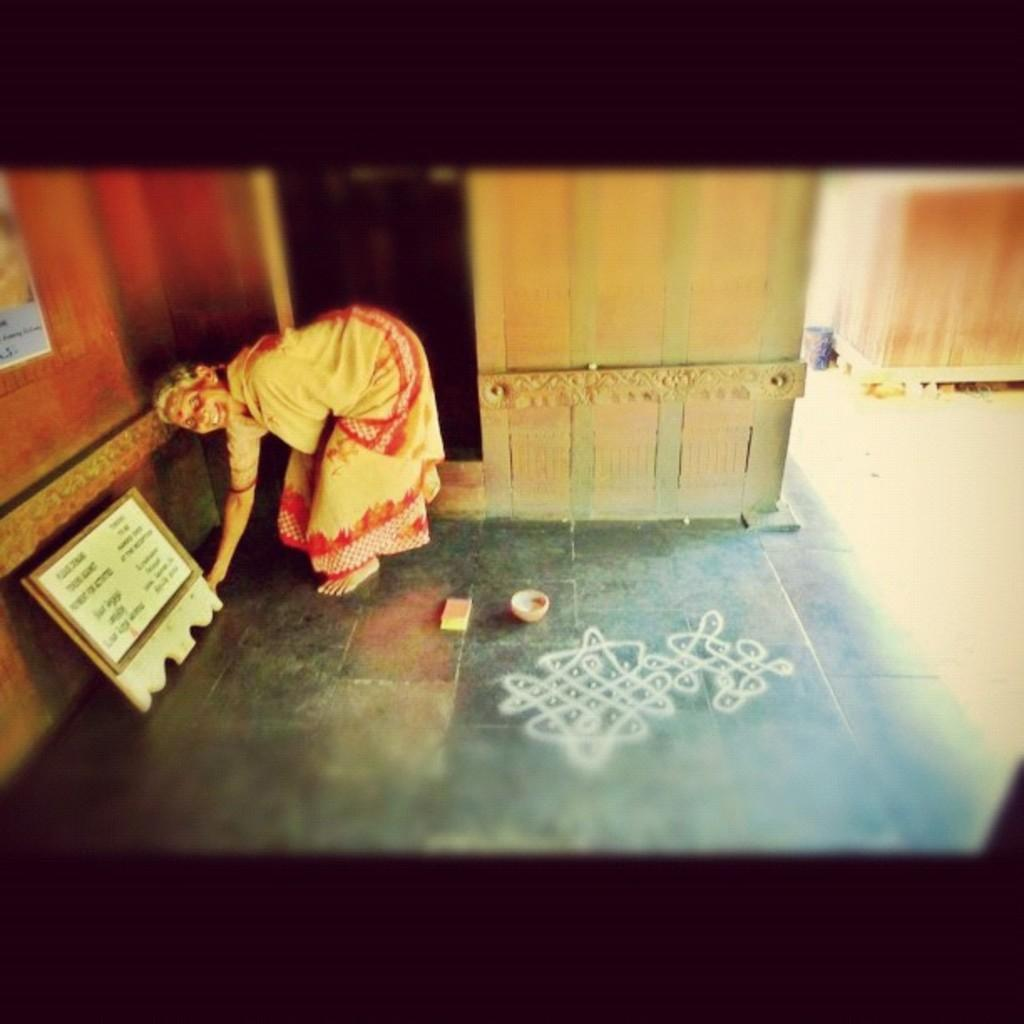Who is the main subject in the image? There is a woman in the image. What is the woman doing in the image? The woman is bending. What can be seen on the left side of the image? There is a board on the left side of the image. What is on the floor in the image? There is a drawing on the floor in the image. What type of battle is taking place in the image? There is no battle present in the image; it features a woman bending and a drawing on the floor. What kind of shop can be seen in the image? There is no shop present in the image. 